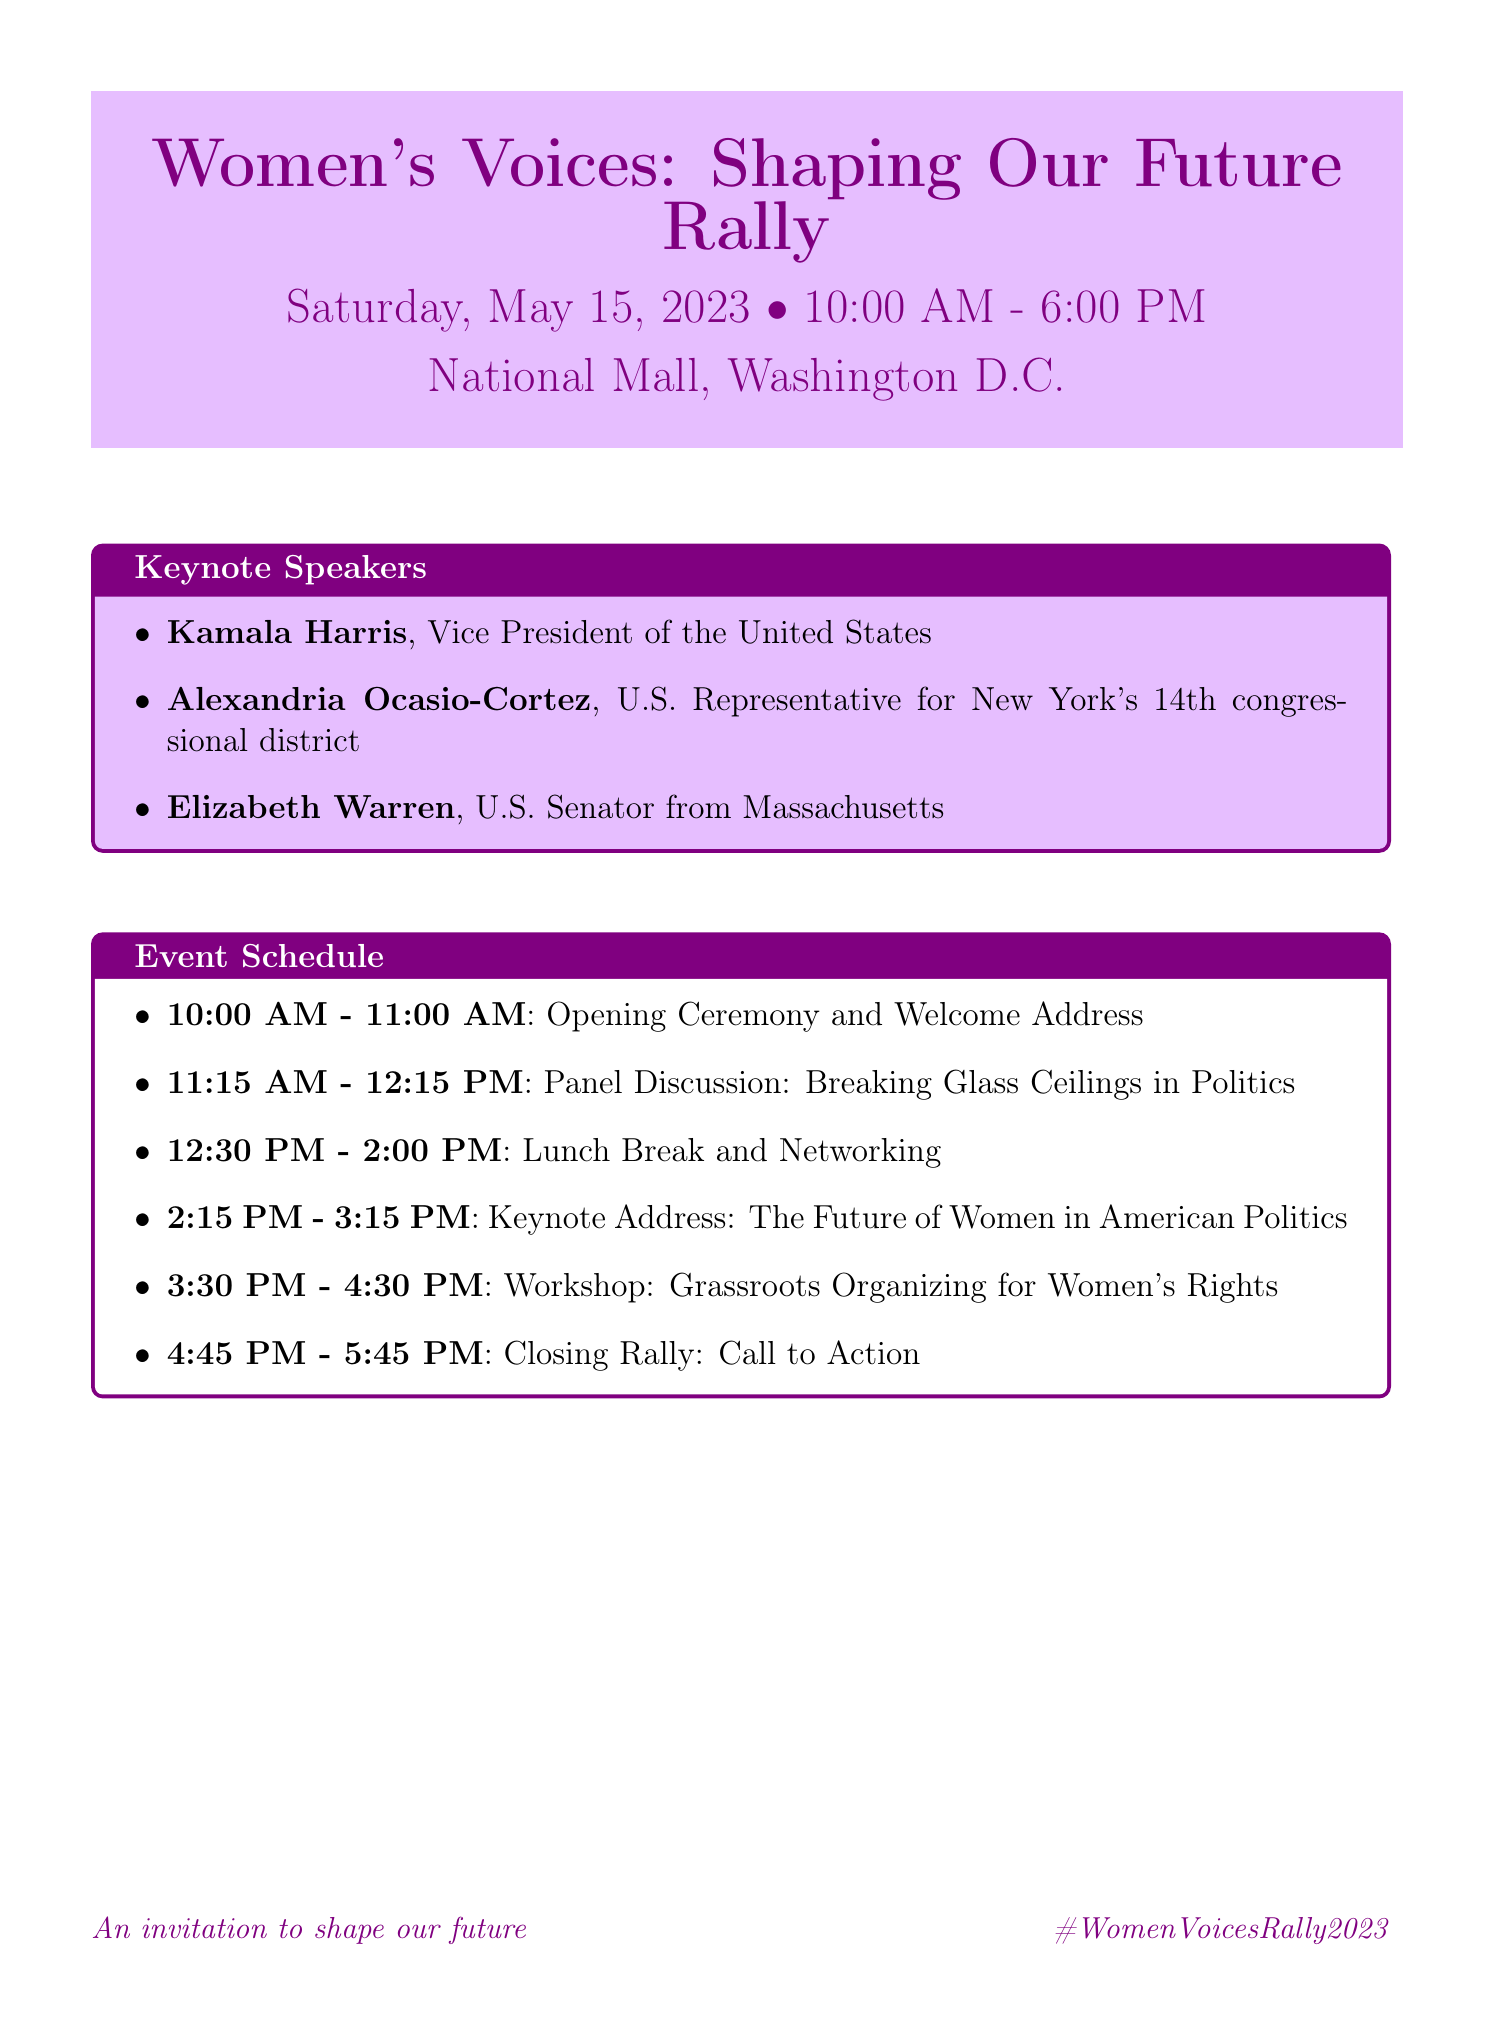What is the date of the rally? The date of the rally is specified directly in the document.
Answer: Saturday, May 15, 2023 Who is the keynote speaker addressing the future of women in American politics? The document lists the keynote addresses and their speakers.
Answer: Kamala Harris What time does the Opening Ceremony begin? The schedule outlines the timing for events, including the Opening Ceremony.
Answer: 10:00 AM Where is the food court located during the event? The venue information indicates where different areas are situated.
Answer: West Potomac Park How long is the lunch break scheduled for? The event schedule indicates the duration of the lunch break.
Answer: 1 hour and 30 minutes Which politician is listed as a facilitator for a workshop? The document details speakers and facilitators for the various sessions.
Answer: Alicia Garza Is there on-site childcare available? The accommodations section mentions services offered at the event.
Answer: Yes What should attendees use to share their experiences on social media? The document provides a designated hashtag for social media engagement.
Answer: #WomenVoicesRally2023 